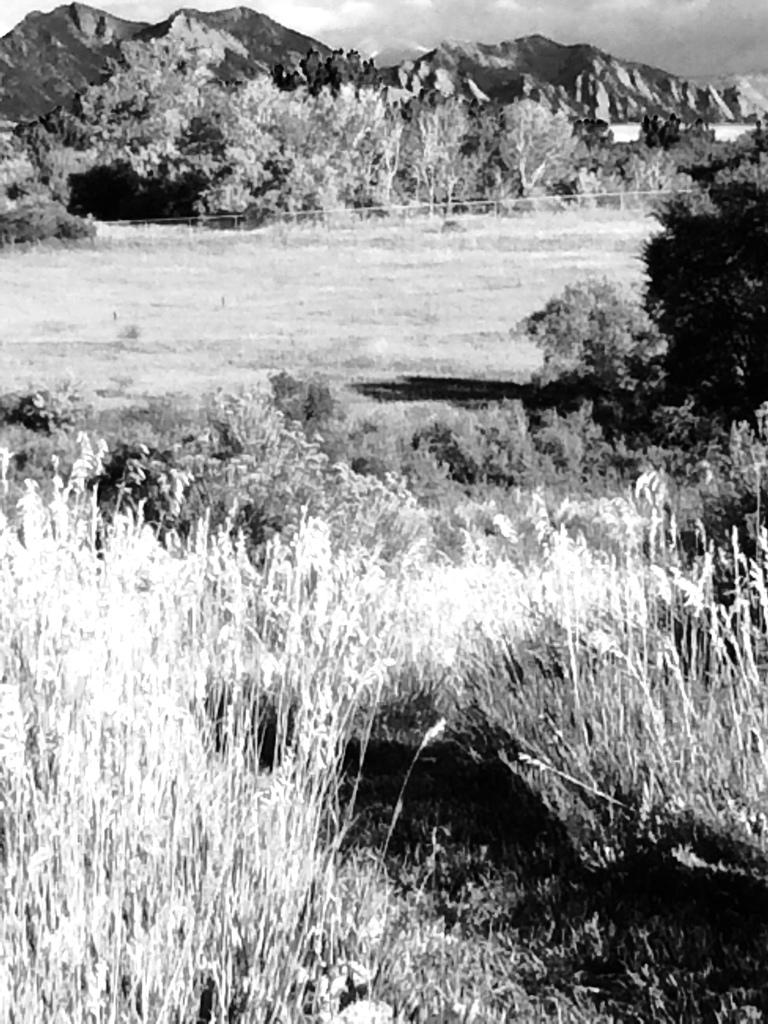What is located in the foreground of the image? There are plants in the foreground of the image. What is in the center of the image? There is land in the center of the image. What can be seen in the background of the image? There are trees and mountains in the background of the image. What type of creature can be seen making a request in the image? There is no creature present in the image, and therefore no such activity can be observed. 